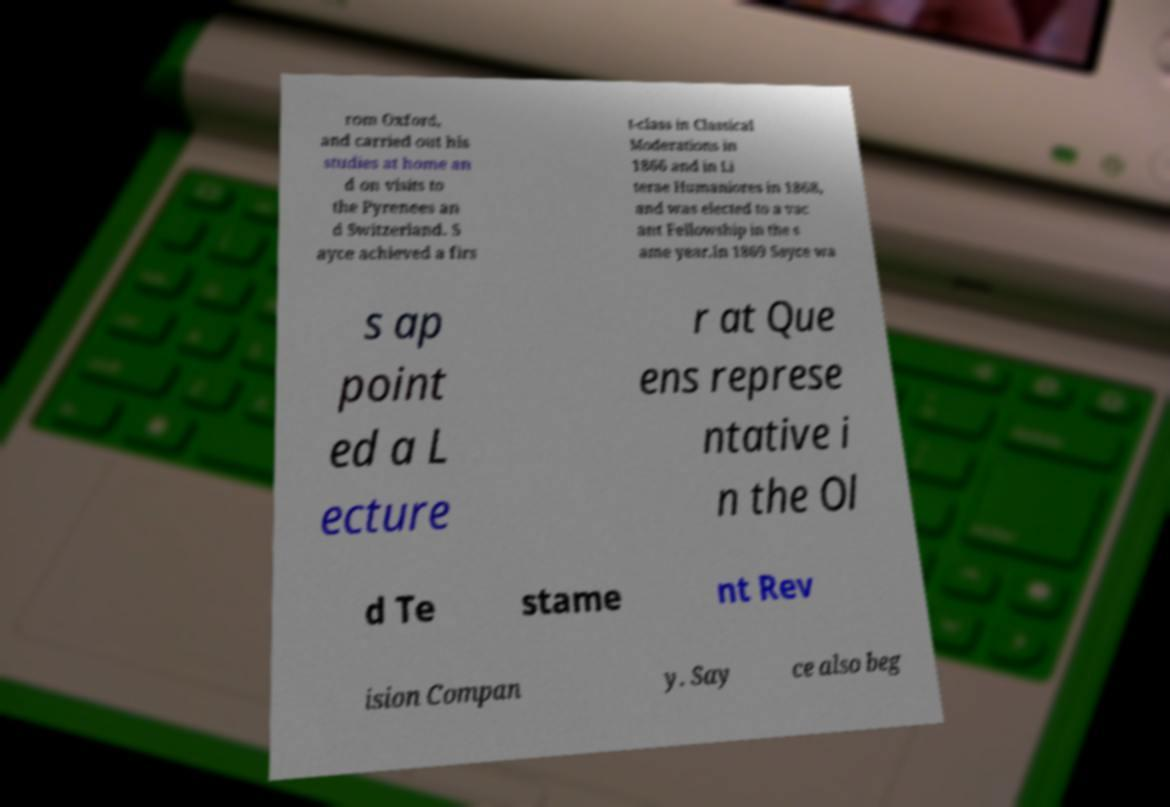For documentation purposes, I need the text within this image transcribed. Could you provide that? rom Oxford, and carried out his studies at home an d on visits to the Pyrenees an d Switzerland. S ayce achieved a firs t-class in Classical Moderations in 1866 and in Li terae Humaniores in 1868, and was elected to a vac ant Fellowship in the s ame year.In 1869 Sayce wa s ap point ed a L ecture r at Que ens represe ntative i n the Ol d Te stame nt Rev ision Compan y. Say ce also beg 